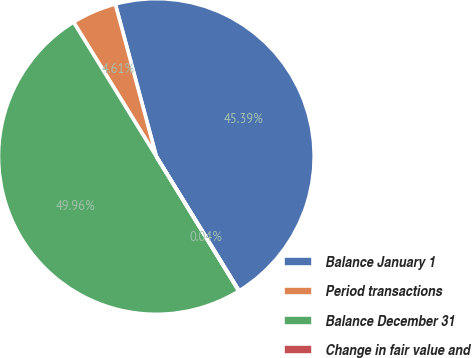<chart> <loc_0><loc_0><loc_500><loc_500><pie_chart><fcel>Balance January 1<fcel>Period transactions<fcel>Balance December 31<fcel>Change in fair value and<nl><fcel>45.39%<fcel>4.61%<fcel>49.96%<fcel>0.04%<nl></chart> 